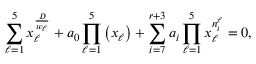<formula> <loc_0><loc_0><loc_500><loc_500>\sum _ { \ell = 1 } ^ { 5 } x _ { \ell } ^ { \frac { D } { w _ { \ell } } } + a _ { 0 } \prod _ { \ell = 1 } ^ { 5 } \left ( x _ { \ell } \right ) + \sum _ { i = 7 } ^ { r + 3 } a _ { i } \prod _ { \ell = 1 } ^ { 5 } x _ { \ell } ^ { n _ { i } ^ { \ell } } = 0 ,</formula> 